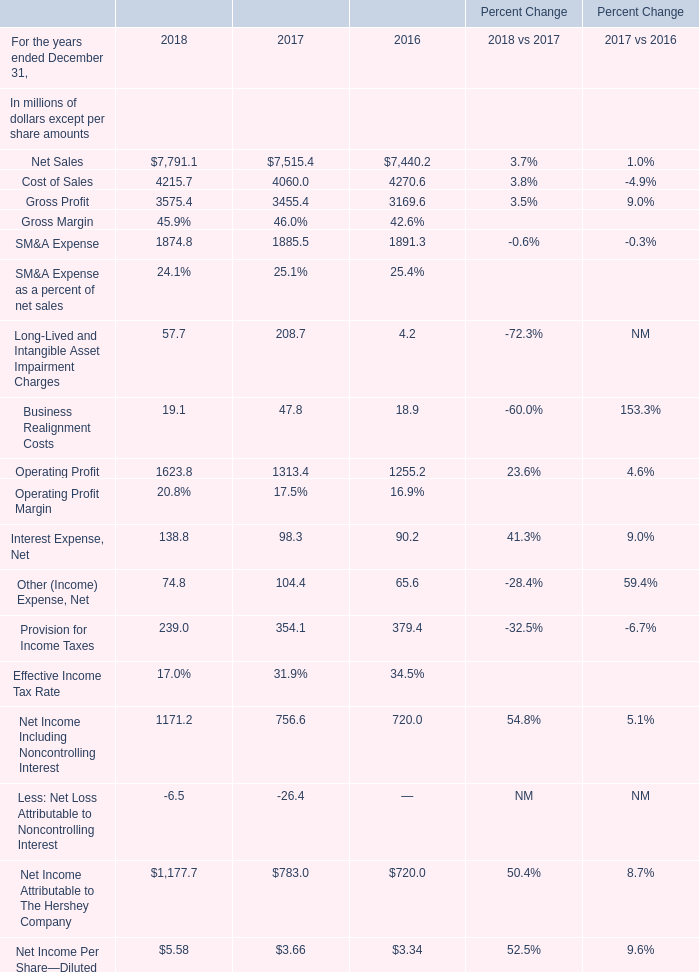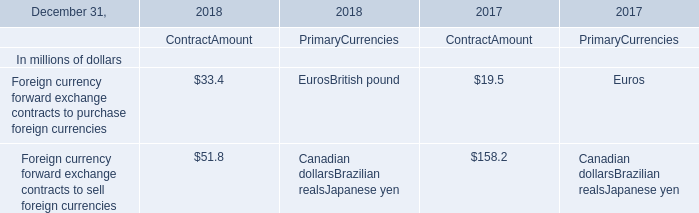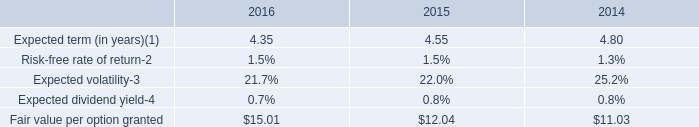What's the increasing rate of Cost of Sales in 2018? 
Computations: ((4215.7 - 4060.0) / 4060)
Answer: 0.03835. 